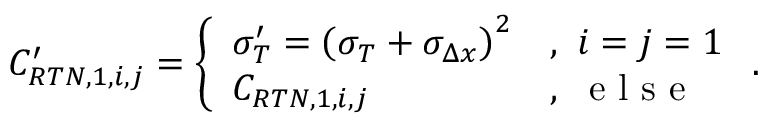Convert formula to latex. <formula><loc_0><loc_0><loc_500><loc_500>C _ { R T N , 1 , { i , j } } ^ { \prime } = \left \{ \begin{array} { l l } { \sigma _ { T } ^ { \prime } = \left ( \sigma _ { T } + \sigma _ { \Delta x } \right ) ^ { 2 } } & { , \ i = j = 1 } \\ { C _ { R T N , 1 , { i , j } } } & { , \ e l s e } \end{array} .</formula> 